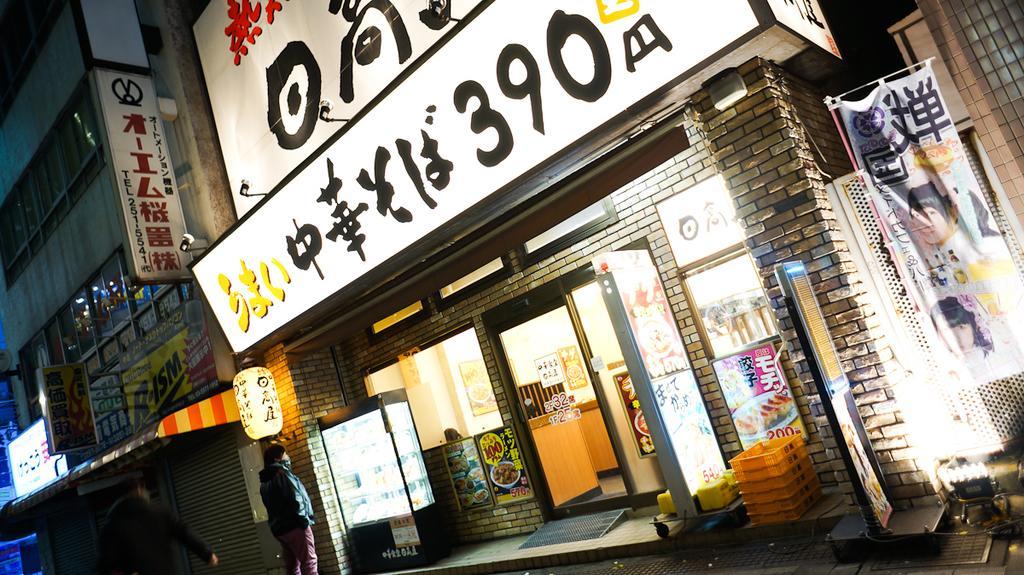Describe this image in one or two sentences. This picture consists of building , on the wall of the building there are holding board and text , in front of the building there are two persons visible and in front of entrance gate of the building there are yellow color trays , refrigerator and a board visible. 